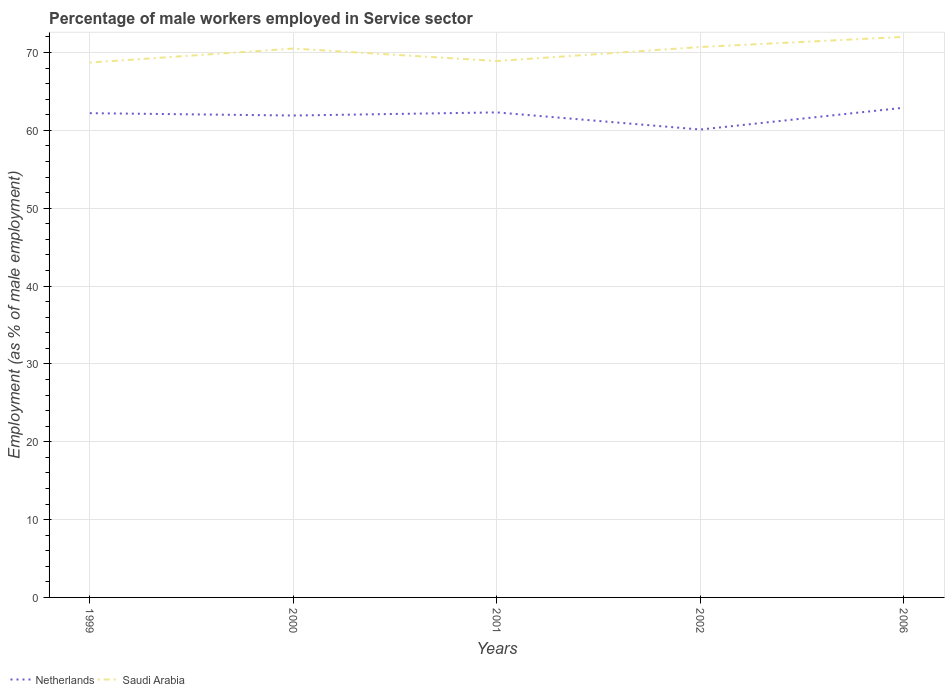How many different coloured lines are there?
Make the answer very short. 2. Does the line corresponding to Saudi Arabia intersect with the line corresponding to Netherlands?
Your answer should be very brief. No. Across all years, what is the maximum percentage of male workers employed in Service sector in Netherlands?
Offer a terse response. 60.1. In which year was the percentage of male workers employed in Service sector in Netherlands maximum?
Provide a short and direct response. 2002. What is the total percentage of male workers employed in Service sector in Netherlands in the graph?
Provide a short and direct response. -0.1. What is the difference between the highest and the second highest percentage of male workers employed in Service sector in Netherlands?
Your response must be concise. 2.8. Is the percentage of male workers employed in Service sector in Saudi Arabia strictly greater than the percentage of male workers employed in Service sector in Netherlands over the years?
Provide a short and direct response. No. What is the difference between two consecutive major ticks on the Y-axis?
Keep it short and to the point. 10. Are the values on the major ticks of Y-axis written in scientific E-notation?
Offer a terse response. No. Does the graph contain grids?
Your answer should be compact. Yes. Where does the legend appear in the graph?
Offer a very short reply. Bottom left. How many legend labels are there?
Give a very brief answer. 2. What is the title of the graph?
Your response must be concise. Percentage of male workers employed in Service sector. Does "Middle income" appear as one of the legend labels in the graph?
Provide a short and direct response. No. What is the label or title of the Y-axis?
Provide a succinct answer. Employment (as % of male employment). What is the Employment (as % of male employment) in Netherlands in 1999?
Provide a short and direct response. 62.2. What is the Employment (as % of male employment) in Saudi Arabia in 1999?
Make the answer very short. 68.7. What is the Employment (as % of male employment) of Netherlands in 2000?
Provide a succinct answer. 61.9. What is the Employment (as % of male employment) of Saudi Arabia in 2000?
Offer a very short reply. 70.5. What is the Employment (as % of male employment) of Netherlands in 2001?
Your answer should be compact. 62.3. What is the Employment (as % of male employment) of Saudi Arabia in 2001?
Make the answer very short. 68.9. What is the Employment (as % of male employment) of Netherlands in 2002?
Provide a succinct answer. 60.1. What is the Employment (as % of male employment) in Saudi Arabia in 2002?
Provide a short and direct response. 70.7. What is the Employment (as % of male employment) in Netherlands in 2006?
Your response must be concise. 62.9. What is the Employment (as % of male employment) in Saudi Arabia in 2006?
Provide a short and direct response. 72. Across all years, what is the maximum Employment (as % of male employment) of Netherlands?
Your response must be concise. 62.9. Across all years, what is the minimum Employment (as % of male employment) of Netherlands?
Ensure brevity in your answer.  60.1. Across all years, what is the minimum Employment (as % of male employment) of Saudi Arabia?
Ensure brevity in your answer.  68.7. What is the total Employment (as % of male employment) in Netherlands in the graph?
Keep it short and to the point. 309.4. What is the total Employment (as % of male employment) in Saudi Arabia in the graph?
Your answer should be very brief. 350.8. What is the difference between the Employment (as % of male employment) of Saudi Arabia in 1999 and that in 2000?
Your answer should be compact. -1.8. What is the difference between the Employment (as % of male employment) of Saudi Arabia in 1999 and that in 2002?
Make the answer very short. -2. What is the difference between the Employment (as % of male employment) in Netherlands in 1999 and that in 2006?
Your response must be concise. -0.7. What is the difference between the Employment (as % of male employment) of Netherlands in 2000 and that in 2002?
Ensure brevity in your answer.  1.8. What is the difference between the Employment (as % of male employment) in Saudi Arabia in 2000 and that in 2002?
Offer a terse response. -0.2. What is the difference between the Employment (as % of male employment) in Saudi Arabia in 2001 and that in 2002?
Make the answer very short. -1.8. What is the difference between the Employment (as % of male employment) of Saudi Arabia in 2002 and that in 2006?
Offer a terse response. -1.3. What is the difference between the Employment (as % of male employment) in Netherlands in 1999 and the Employment (as % of male employment) in Saudi Arabia in 2006?
Make the answer very short. -9.8. What is the difference between the Employment (as % of male employment) in Netherlands in 2000 and the Employment (as % of male employment) in Saudi Arabia in 2001?
Your answer should be very brief. -7. What is the difference between the Employment (as % of male employment) in Netherlands in 2001 and the Employment (as % of male employment) in Saudi Arabia in 2002?
Offer a terse response. -8.4. What is the difference between the Employment (as % of male employment) of Netherlands in 2001 and the Employment (as % of male employment) of Saudi Arabia in 2006?
Provide a short and direct response. -9.7. What is the difference between the Employment (as % of male employment) of Netherlands in 2002 and the Employment (as % of male employment) of Saudi Arabia in 2006?
Provide a short and direct response. -11.9. What is the average Employment (as % of male employment) of Netherlands per year?
Provide a succinct answer. 61.88. What is the average Employment (as % of male employment) of Saudi Arabia per year?
Your answer should be very brief. 70.16. In the year 2000, what is the difference between the Employment (as % of male employment) in Netherlands and Employment (as % of male employment) in Saudi Arabia?
Your answer should be compact. -8.6. In the year 2002, what is the difference between the Employment (as % of male employment) of Netherlands and Employment (as % of male employment) of Saudi Arabia?
Ensure brevity in your answer.  -10.6. In the year 2006, what is the difference between the Employment (as % of male employment) in Netherlands and Employment (as % of male employment) in Saudi Arabia?
Your answer should be very brief. -9.1. What is the ratio of the Employment (as % of male employment) of Saudi Arabia in 1999 to that in 2000?
Keep it short and to the point. 0.97. What is the ratio of the Employment (as % of male employment) in Netherlands in 1999 to that in 2001?
Your answer should be very brief. 1. What is the ratio of the Employment (as % of male employment) of Saudi Arabia in 1999 to that in 2001?
Your answer should be compact. 1. What is the ratio of the Employment (as % of male employment) of Netherlands in 1999 to that in 2002?
Ensure brevity in your answer.  1.03. What is the ratio of the Employment (as % of male employment) of Saudi Arabia in 1999 to that in 2002?
Provide a succinct answer. 0.97. What is the ratio of the Employment (as % of male employment) in Netherlands in 1999 to that in 2006?
Provide a succinct answer. 0.99. What is the ratio of the Employment (as % of male employment) in Saudi Arabia in 1999 to that in 2006?
Offer a very short reply. 0.95. What is the ratio of the Employment (as % of male employment) of Netherlands in 2000 to that in 2001?
Keep it short and to the point. 0.99. What is the ratio of the Employment (as % of male employment) in Saudi Arabia in 2000 to that in 2001?
Offer a terse response. 1.02. What is the ratio of the Employment (as % of male employment) in Netherlands in 2000 to that in 2002?
Offer a very short reply. 1.03. What is the ratio of the Employment (as % of male employment) of Saudi Arabia in 2000 to that in 2002?
Your response must be concise. 1. What is the ratio of the Employment (as % of male employment) in Netherlands in 2000 to that in 2006?
Your response must be concise. 0.98. What is the ratio of the Employment (as % of male employment) in Saudi Arabia in 2000 to that in 2006?
Ensure brevity in your answer.  0.98. What is the ratio of the Employment (as % of male employment) of Netherlands in 2001 to that in 2002?
Your answer should be very brief. 1.04. What is the ratio of the Employment (as % of male employment) of Saudi Arabia in 2001 to that in 2002?
Provide a short and direct response. 0.97. What is the ratio of the Employment (as % of male employment) of Saudi Arabia in 2001 to that in 2006?
Ensure brevity in your answer.  0.96. What is the ratio of the Employment (as % of male employment) in Netherlands in 2002 to that in 2006?
Keep it short and to the point. 0.96. What is the ratio of the Employment (as % of male employment) of Saudi Arabia in 2002 to that in 2006?
Your answer should be compact. 0.98. What is the difference between the highest and the second highest Employment (as % of male employment) of Netherlands?
Keep it short and to the point. 0.6. What is the difference between the highest and the lowest Employment (as % of male employment) in Netherlands?
Provide a short and direct response. 2.8. What is the difference between the highest and the lowest Employment (as % of male employment) in Saudi Arabia?
Offer a very short reply. 3.3. 